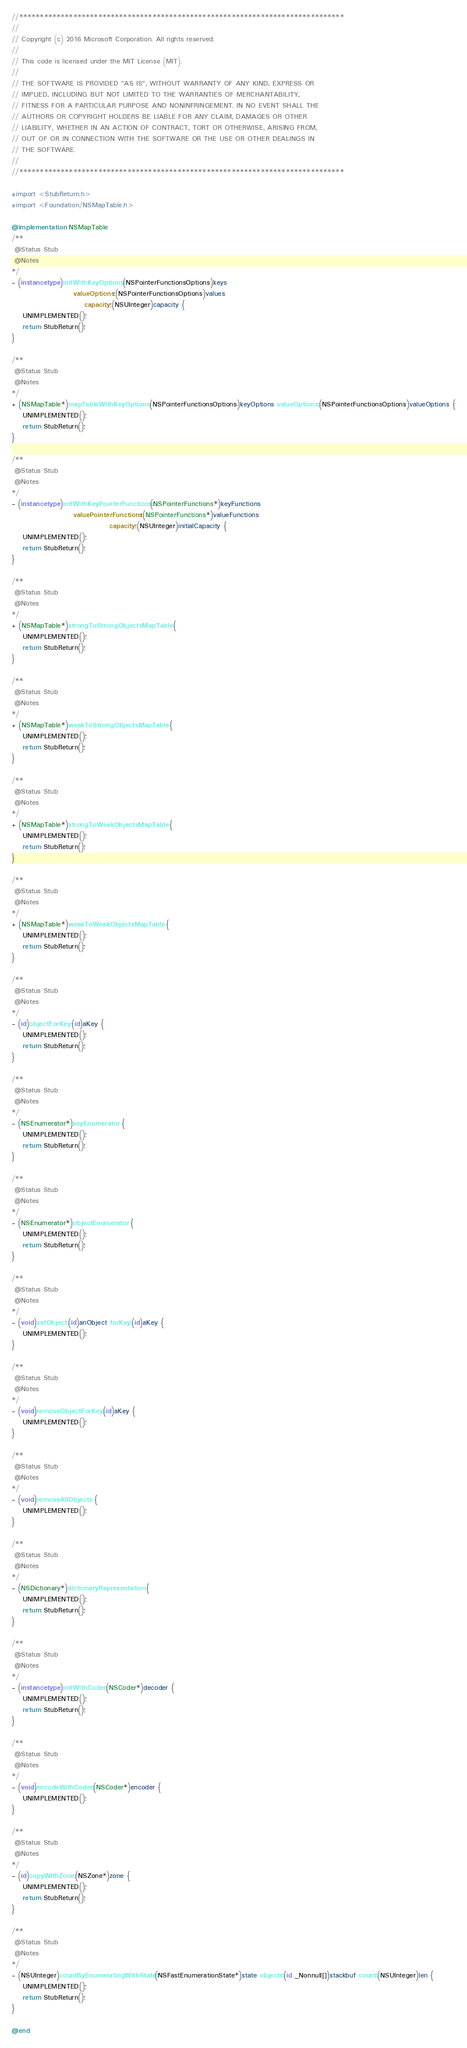Convert code to text. <code><loc_0><loc_0><loc_500><loc_500><_ObjectiveC_>//******************************************************************************
//
// Copyright (c) 2016 Microsoft Corporation. All rights reserved.
//
// This code is licensed under the MIT License (MIT).
//
// THE SOFTWARE IS PROVIDED "AS IS", WITHOUT WARRANTY OF ANY KIND, EXPRESS OR
// IMPLIED, INCLUDING BUT NOT LIMITED TO THE WARRANTIES OF MERCHANTABILITY,
// FITNESS FOR A PARTICULAR PURPOSE AND NONINFRINGEMENT. IN NO EVENT SHALL THE
// AUTHORS OR COPYRIGHT HOLDERS BE LIABLE FOR ANY CLAIM, DAMAGES OR OTHER
// LIABILITY, WHETHER IN AN ACTION OF CONTRACT, TORT OR OTHERWISE, ARISING FROM,
// OUT OF OR IN CONNECTION WITH THE SOFTWARE OR THE USE OR OTHER DEALINGS IN
// THE SOFTWARE.
//
//******************************************************************************

#import <StubReturn.h>
#import <Foundation/NSMapTable.h>

@implementation NSMapTable
/**
 @Status Stub
 @Notes
*/
- (instancetype)initWithKeyOptions:(NSPointerFunctionsOptions)keys
                      valueOptions:(NSPointerFunctionsOptions)values
                          capacity:(NSUInteger)capacity {
    UNIMPLEMENTED();
    return StubReturn();
}

/**
 @Status Stub
 @Notes
*/
+ (NSMapTable*)mapTableWithKeyOptions:(NSPointerFunctionsOptions)keyOptions valueOptions:(NSPointerFunctionsOptions)valueOptions {
    UNIMPLEMENTED();
    return StubReturn();
}

/**
 @Status Stub
 @Notes
*/
- (instancetype)initWithKeyPointerFunctions:(NSPointerFunctions*)keyFunctions
                      valuePointerFunctions:(NSPointerFunctions*)valueFunctions
                                   capacity:(NSUInteger)initialCapacity {
    UNIMPLEMENTED();
    return StubReturn();
}

/**
 @Status Stub
 @Notes
*/
+ (NSMapTable*)strongToStrongObjectsMapTable {
    UNIMPLEMENTED();
    return StubReturn();
}

/**
 @Status Stub
 @Notes
*/
+ (NSMapTable*)weakToStrongObjectsMapTable {
    UNIMPLEMENTED();
    return StubReturn();
}

/**
 @Status Stub
 @Notes
*/
+ (NSMapTable*)strongToWeakObjectsMapTable {
    UNIMPLEMENTED();
    return StubReturn();
}

/**
 @Status Stub
 @Notes
*/
+ (NSMapTable*)weakToWeakObjectsMapTable {
    UNIMPLEMENTED();
    return StubReturn();
}

/**
 @Status Stub
 @Notes
*/
- (id)objectForKey:(id)aKey {
    UNIMPLEMENTED();
    return StubReturn();
}

/**
 @Status Stub
 @Notes
*/
- (NSEnumerator*)keyEnumerator {
    UNIMPLEMENTED();
    return StubReturn();
}

/**
 @Status Stub
 @Notes
*/
- (NSEnumerator*)objectEnumerator {
    UNIMPLEMENTED();
    return StubReturn();
}

/**
 @Status Stub
 @Notes
*/
- (void)setObject:(id)anObject forKey:(id)aKey {
    UNIMPLEMENTED();
}

/**
 @Status Stub
 @Notes
*/
- (void)removeObjectForKey:(id)aKey {
    UNIMPLEMENTED();
}

/**
 @Status Stub
 @Notes
*/
- (void)removeAllObjects {
    UNIMPLEMENTED();
}

/**
 @Status Stub
 @Notes
*/
- (NSDictionary*)dictionaryRepresentation {
    UNIMPLEMENTED();
    return StubReturn();
}

/**
 @Status Stub
 @Notes
*/
- (instancetype)initWithCoder:(NSCoder*)decoder {
    UNIMPLEMENTED();
    return StubReturn();
}

/**
 @Status Stub
 @Notes
*/
- (void)encodeWithCoder:(NSCoder*)encoder {
    UNIMPLEMENTED();
}

/**
 @Status Stub
 @Notes
*/
- (id)copyWithZone:(NSZone*)zone {
    UNIMPLEMENTED();
    return StubReturn();
}

/**
 @Status Stub
 @Notes
*/
- (NSUInteger)countByEnumeratingWithState:(NSFastEnumerationState*)state objects:(id _Nonnull[])stackbuf count:(NSUInteger)len {
    UNIMPLEMENTED();
    return StubReturn();
}

@end
</code> 